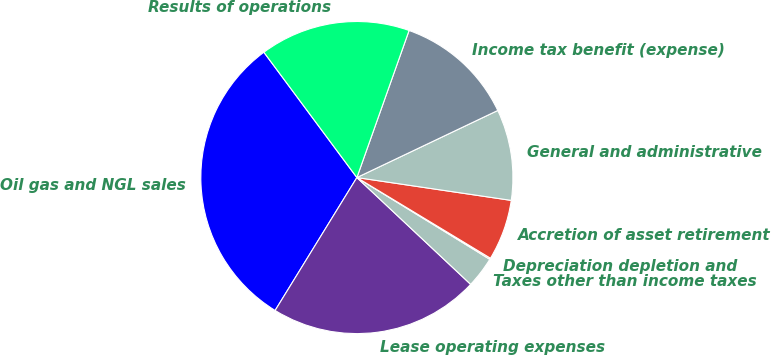Convert chart to OTSL. <chart><loc_0><loc_0><loc_500><loc_500><pie_chart><fcel>Oil gas and NGL sales<fcel>Lease operating expenses<fcel>Taxes other than income taxes<fcel>Depreciation depletion and<fcel>Accretion of asset retirement<fcel>General and administrative<fcel>Income tax benefit (expense)<fcel>Results of operations<nl><fcel>31.06%<fcel>21.78%<fcel>3.22%<fcel>0.13%<fcel>6.31%<fcel>9.41%<fcel>12.5%<fcel>15.59%<nl></chart> 